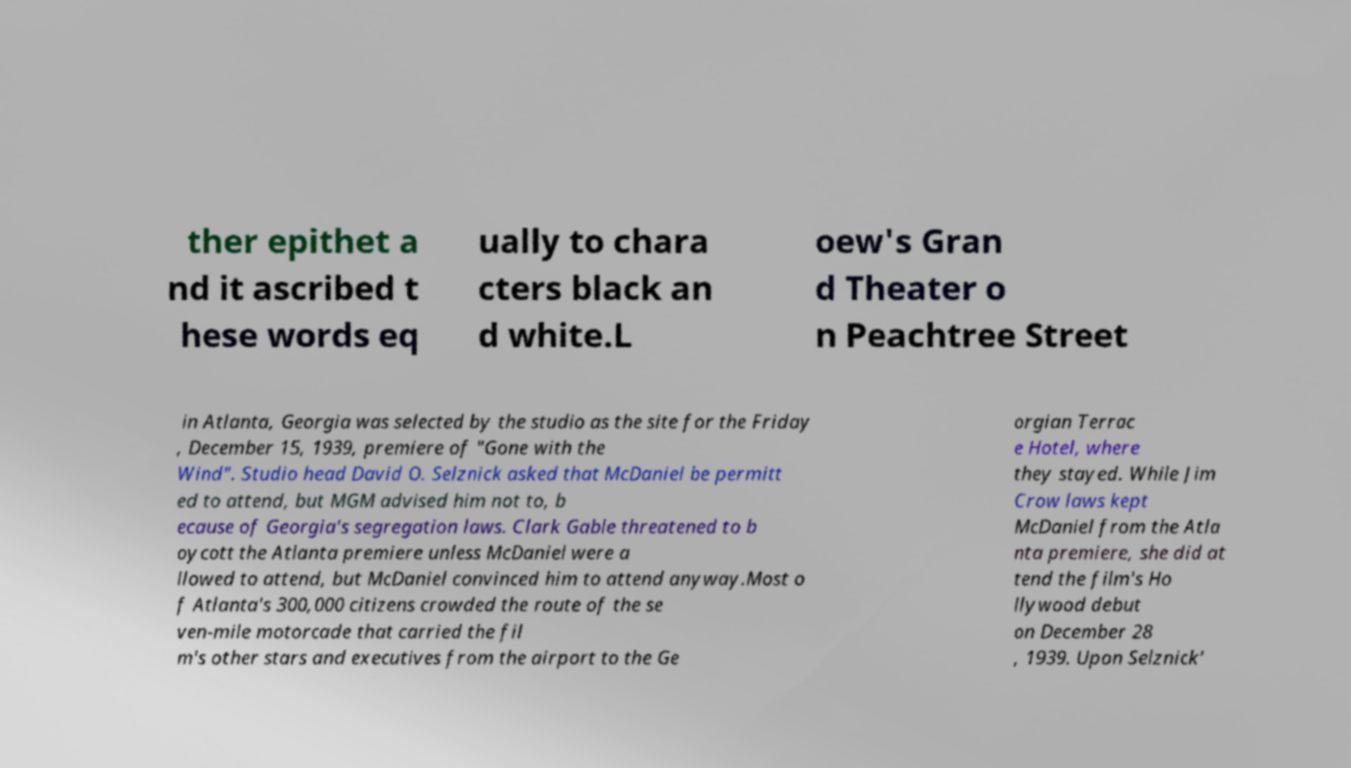Can you read and provide the text displayed in the image?This photo seems to have some interesting text. Can you extract and type it out for me? ther epithet a nd it ascribed t hese words eq ually to chara cters black an d white.L oew's Gran d Theater o n Peachtree Street in Atlanta, Georgia was selected by the studio as the site for the Friday , December 15, 1939, premiere of "Gone with the Wind". Studio head David O. Selznick asked that McDaniel be permitt ed to attend, but MGM advised him not to, b ecause of Georgia's segregation laws. Clark Gable threatened to b oycott the Atlanta premiere unless McDaniel were a llowed to attend, but McDaniel convinced him to attend anyway.Most o f Atlanta's 300,000 citizens crowded the route of the se ven-mile motorcade that carried the fil m's other stars and executives from the airport to the Ge orgian Terrac e Hotel, where they stayed. While Jim Crow laws kept McDaniel from the Atla nta premiere, she did at tend the film's Ho llywood debut on December 28 , 1939. Upon Selznick' 